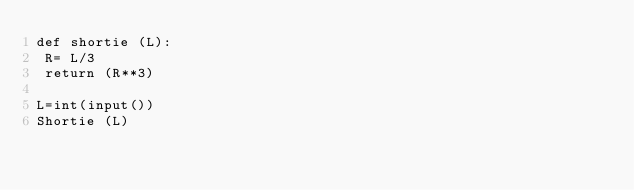<code> <loc_0><loc_0><loc_500><loc_500><_Python_>def shortie (L):
 R= L/3
 return (R**3)

L=int(input())
Shortie (L)</code> 